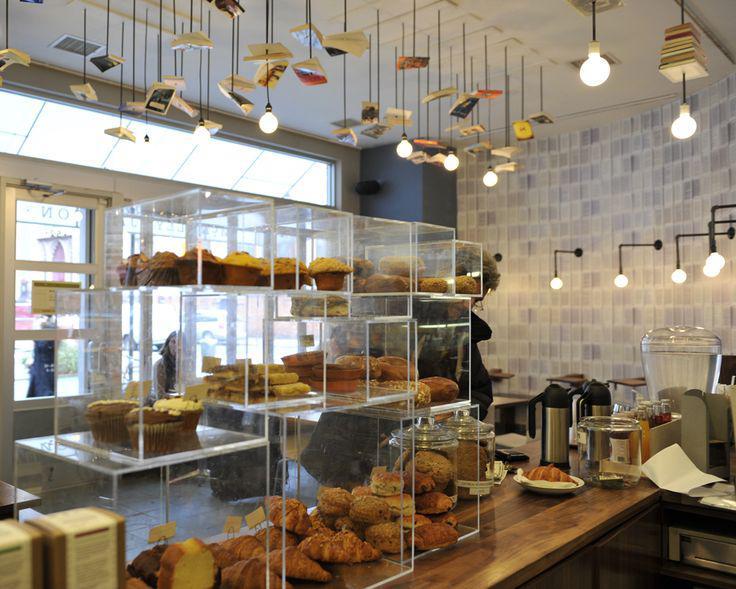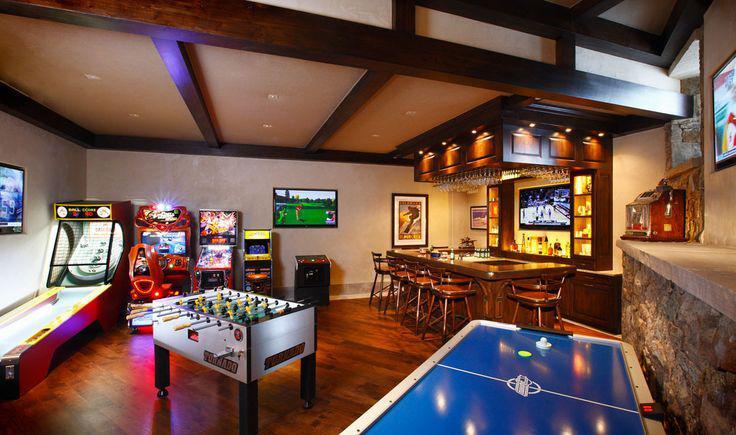The first image is the image on the left, the second image is the image on the right. Given the left and right images, does the statement "Both images in the pair show a cafe where coffee or pastries are served." hold true? Answer yes or no. No. The first image is the image on the left, the second image is the image on the right. Analyze the images presented: Is the assertion "There are stools at the bar." valid? Answer yes or no. Yes. 